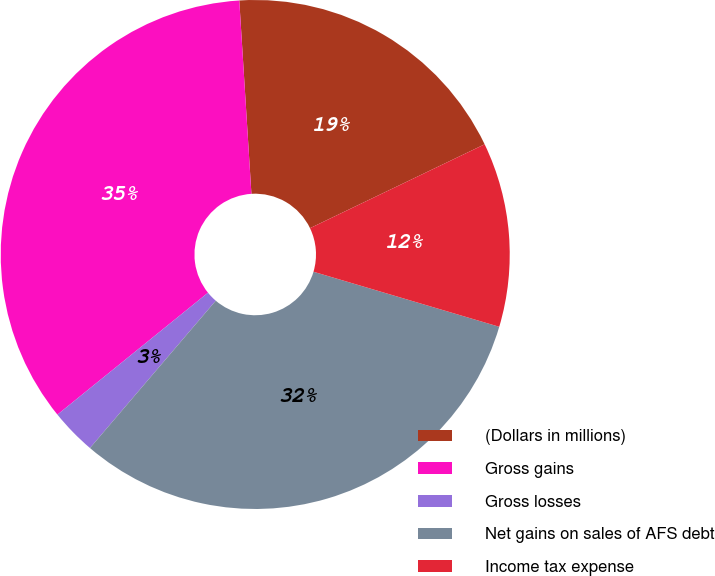<chart> <loc_0><loc_0><loc_500><loc_500><pie_chart><fcel>(Dollars in millions)<fcel>Gross gains<fcel>Gross losses<fcel>Net gains on sales of AFS debt<fcel>Income tax expense<nl><fcel>18.87%<fcel>34.83%<fcel>2.92%<fcel>31.66%<fcel>11.71%<nl></chart> 